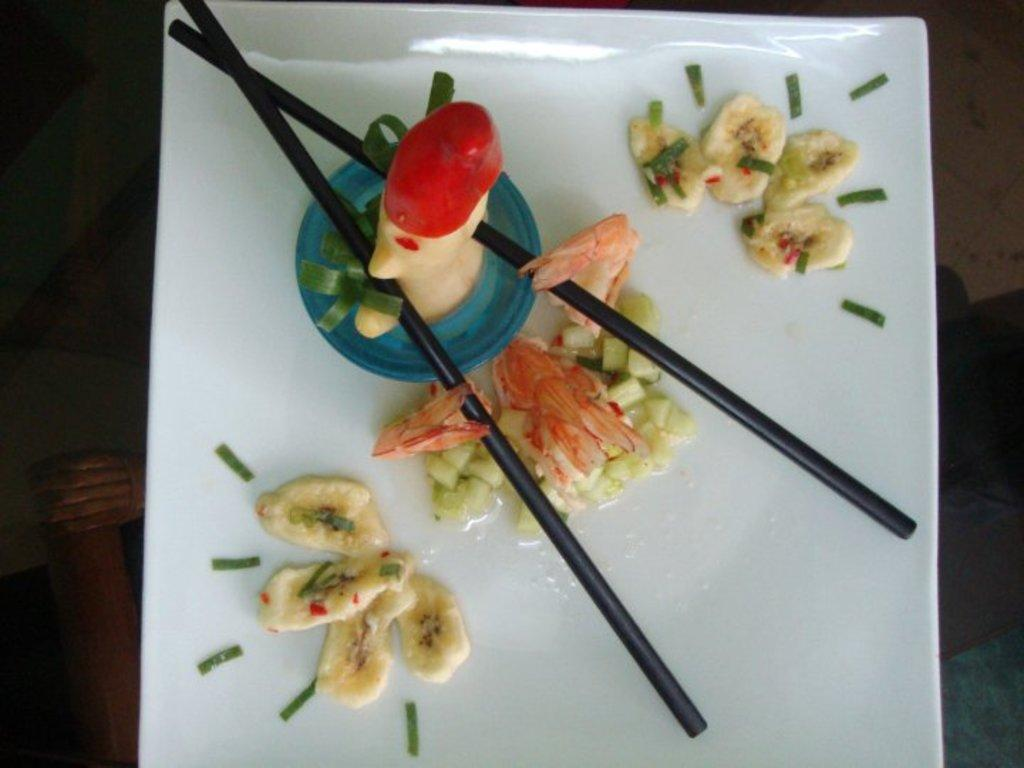What is present on the plate in the image? There are eatables on the plate in the image. What color is the plate? The plate is white. What utensils are visible in the image? Chopsticks are visible in the image. What color are the chopsticks? The chopsticks are black. Can you see a boot being used to stir the vegetable on the plate? There is no boot or vegetable present in the image; it only features a plate with eatables and chopsticks. 